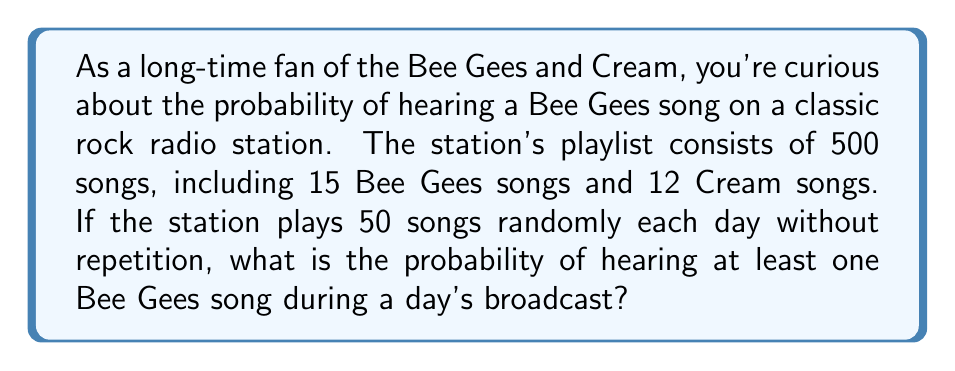Provide a solution to this math problem. Let's approach this step-by-step using the complementary probability method:

1) First, we'll calculate the probability of not hearing any Bee Gees songs.

2) The total number of songs in the playlist: $n = 500$
   The number of Bee Gees songs: $k = 15$
   The number of songs played each day: $r = 50$

3) The probability of not selecting a Bee Gees song in one draw is:

   $$P(\text{no Bee Gees}) = \frac{500-15}{500} = \frac{485}{500}$$

4) For all 50 songs to not be Bee Gees songs, this needs to happen 50 times in a row. We can calculate this using the multiplication rule of probability:

   $$P(\text{no Bee Gees in 50 songs}) = \left(\frac{485}{500}\right) \times \left(\frac{484}{499}\right) \times \left(\frac{483}{498}\right) \times ... \times \left(\frac{436}{451}\right)$$

5) This can be written more concisely using the combination formula:

   $$P(\text{no Bee Gees in 50 songs}) = \frac{\binom{485}{50}}{\binom{500}{50}}$$

6) Using a calculator or computer to evaluate this:

   $$P(\text{no Bee Gees in 50 songs}) \approx 0.2180$$

7) Therefore, the probability of hearing at least one Bee Gees song is the complement of this probability:

   $$P(\text{at least one Bee Gees song}) = 1 - P(\text{no Bee Gees in 50 songs})$$
   $$= 1 - 0.2180 \approx 0.7820$$

Thus, there is approximately a 78.20% chance of hearing at least one Bee Gees song during a day's broadcast.
Answer: The probability of hearing at least one Bee Gees song during a day's broadcast is approximately 0.7820 or 78.20%. 